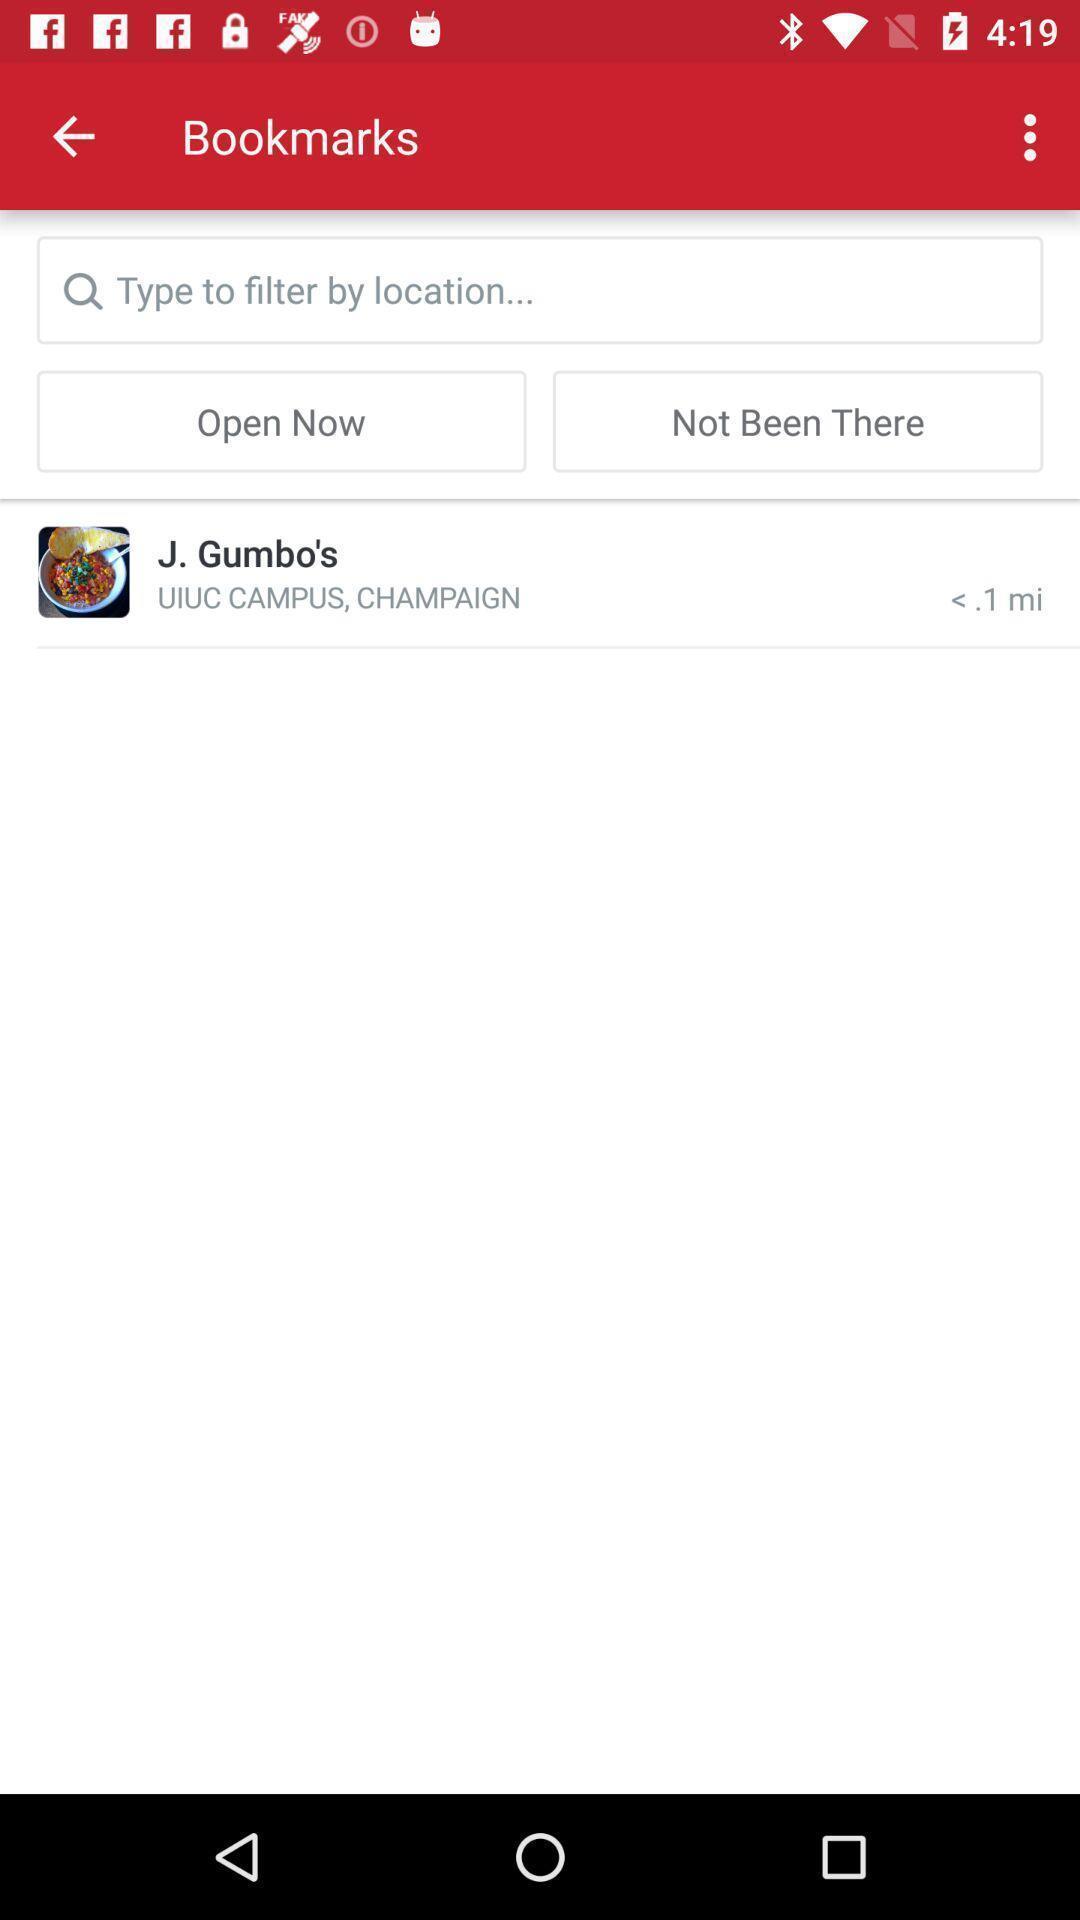Give me a summary of this screen capture. Screen displaying the bookmarks of a food delivery app. 